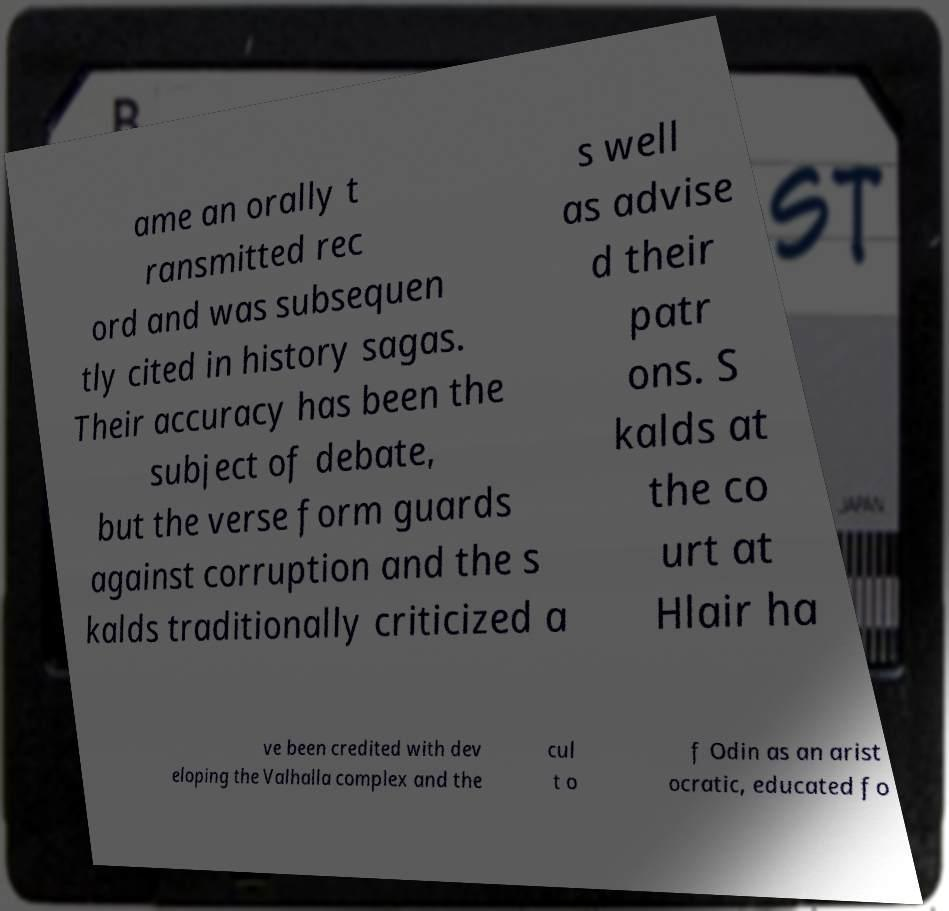Please read and relay the text visible in this image. What does it say? ame an orally t ransmitted rec ord and was subsequen tly cited in history sagas. Their accuracy has been the subject of debate, but the verse form guards against corruption and the s kalds traditionally criticized a s well as advise d their patr ons. S kalds at the co urt at Hlair ha ve been credited with dev eloping the Valhalla complex and the cul t o f Odin as an arist ocratic, educated fo 